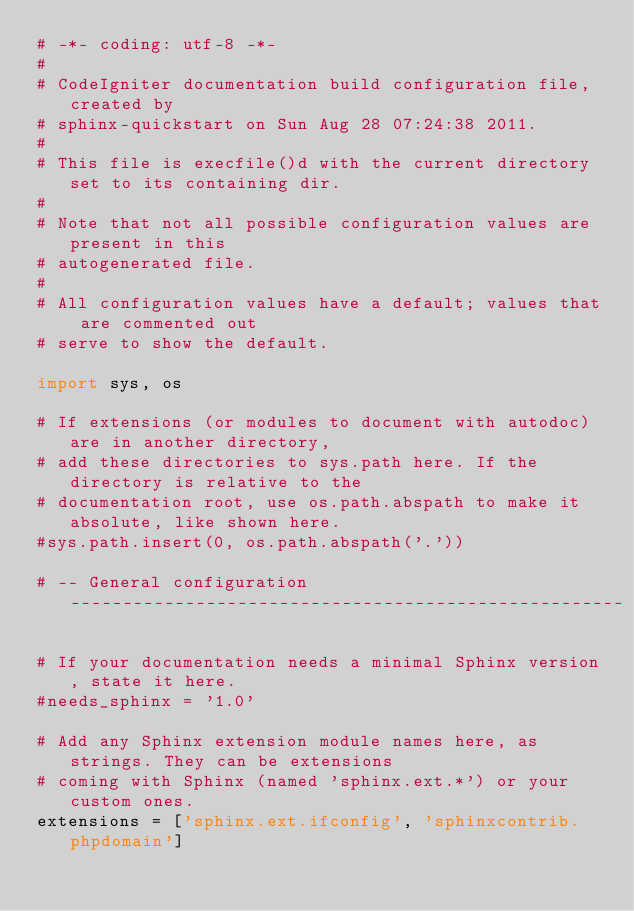<code> <loc_0><loc_0><loc_500><loc_500><_Python_># -*- coding: utf-8 -*-
#
# CodeIgniter documentation build configuration file, created by
# sphinx-quickstart on Sun Aug 28 07:24:38 2011.
#
# This file is execfile()d with the current directory set to its containing dir.
#
# Note that not all possible configuration values are present in this
# autogenerated file.
#
# All configuration values have a default; values that are commented out
# serve to show the default.

import sys, os

# If extensions (or modules to document with autodoc) are in another directory,
# add these directories to sys.path here. If the directory is relative to the
# documentation root, use os.path.abspath to make it absolute, like shown here.
#sys.path.insert(0, os.path.abspath('.'))

# -- General configuration -----------------------------------------------------

# If your documentation needs a minimal Sphinx version, state it here.
#needs_sphinx = '1.0'

# Add any Sphinx extension module names here, as strings. They can be extensions
# coming with Sphinx (named 'sphinx.ext.*') or your custom ones.
extensions = ['sphinx.ext.ifconfig', 'sphinxcontrib.phpdomain']
</code> 